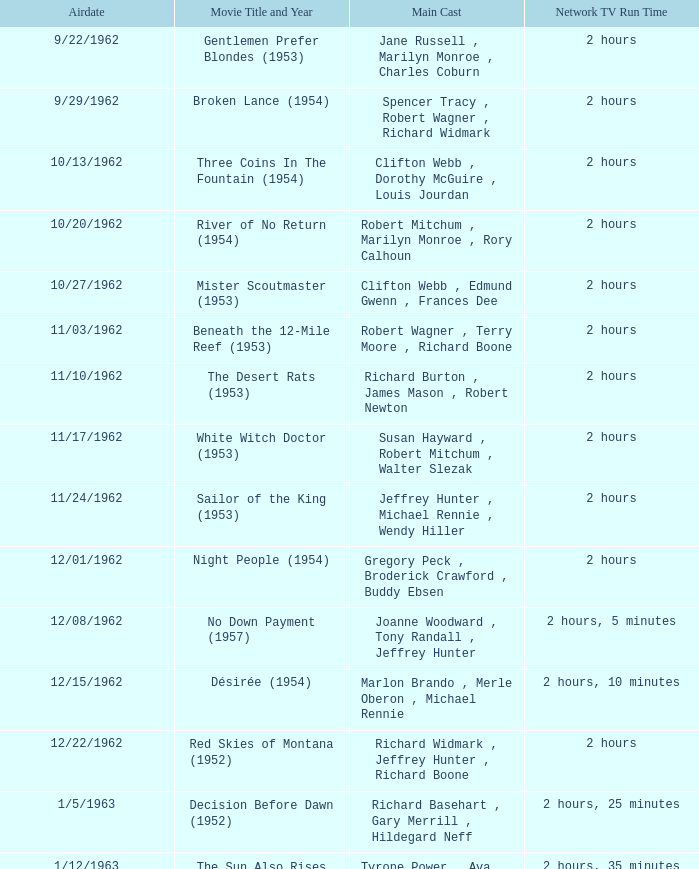Who was the cast on the 3/23/1963 episode? Dana Wynter , Mel Ferrer , Theodore Bikel. 